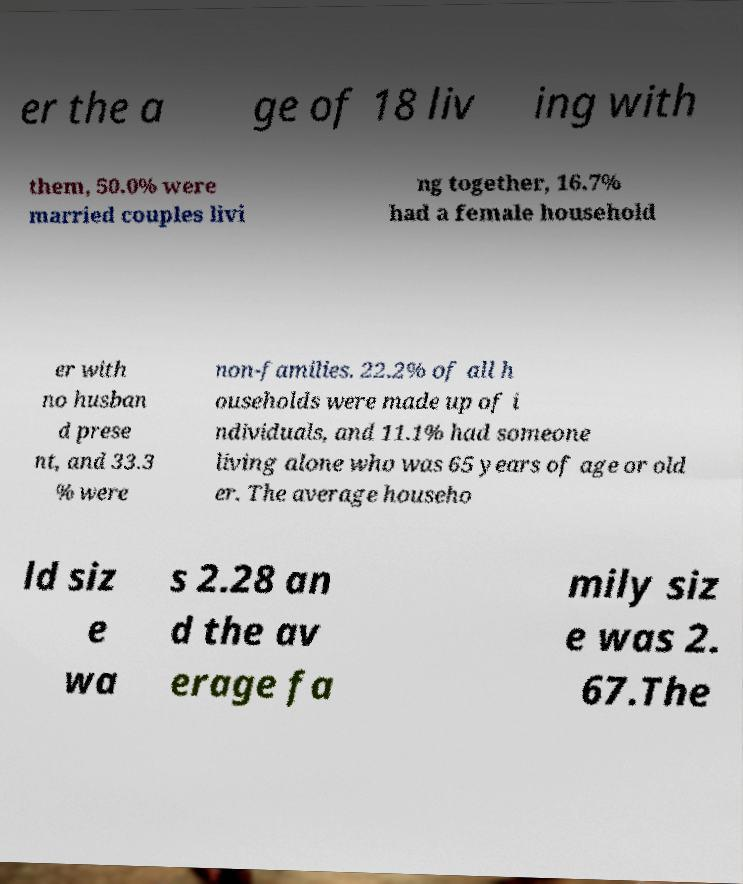For documentation purposes, I need the text within this image transcribed. Could you provide that? er the a ge of 18 liv ing with them, 50.0% were married couples livi ng together, 16.7% had a female household er with no husban d prese nt, and 33.3 % were non-families. 22.2% of all h ouseholds were made up of i ndividuals, and 11.1% had someone living alone who was 65 years of age or old er. The average househo ld siz e wa s 2.28 an d the av erage fa mily siz e was 2. 67.The 